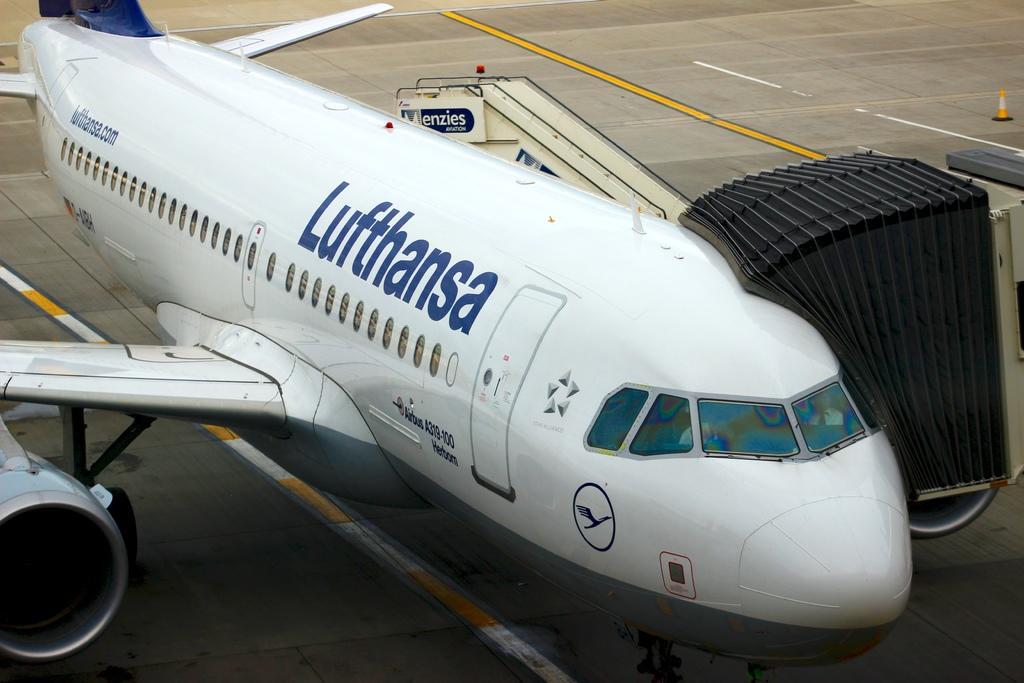In one or two sentences, can you explain what this image depicts? In this image there is an airplane on the concrete surface. On the right side of the image there is a traffic cone cup. 